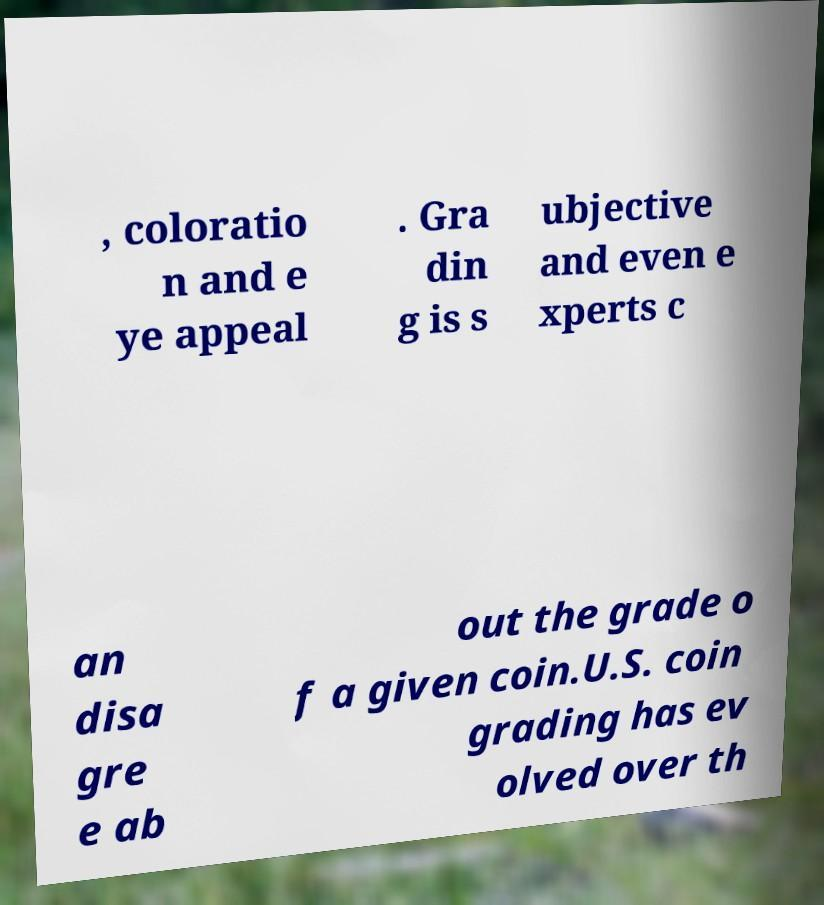Please read and relay the text visible in this image. What does it say? , coloratio n and e ye appeal . Gra din g is s ubjective and even e xperts c an disa gre e ab out the grade o f a given coin.U.S. coin grading has ev olved over th 